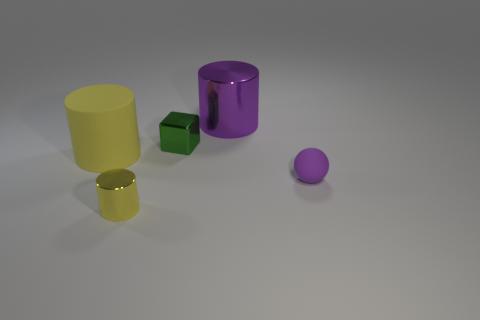How many yellow cylinders must be subtracted to get 1 yellow cylinders? 1 Add 3 yellow things. How many objects exist? 8 Subtract all spheres. How many objects are left? 4 Add 5 cylinders. How many cylinders are left? 8 Add 3 purple shiny objects. How many purple shiny objects exist? 4 Subtract 1 green cubes. How many objects are left? 4 Subtract all red metal cylinders. Subtract all small purple rubber balls. How many objects are left? 4 